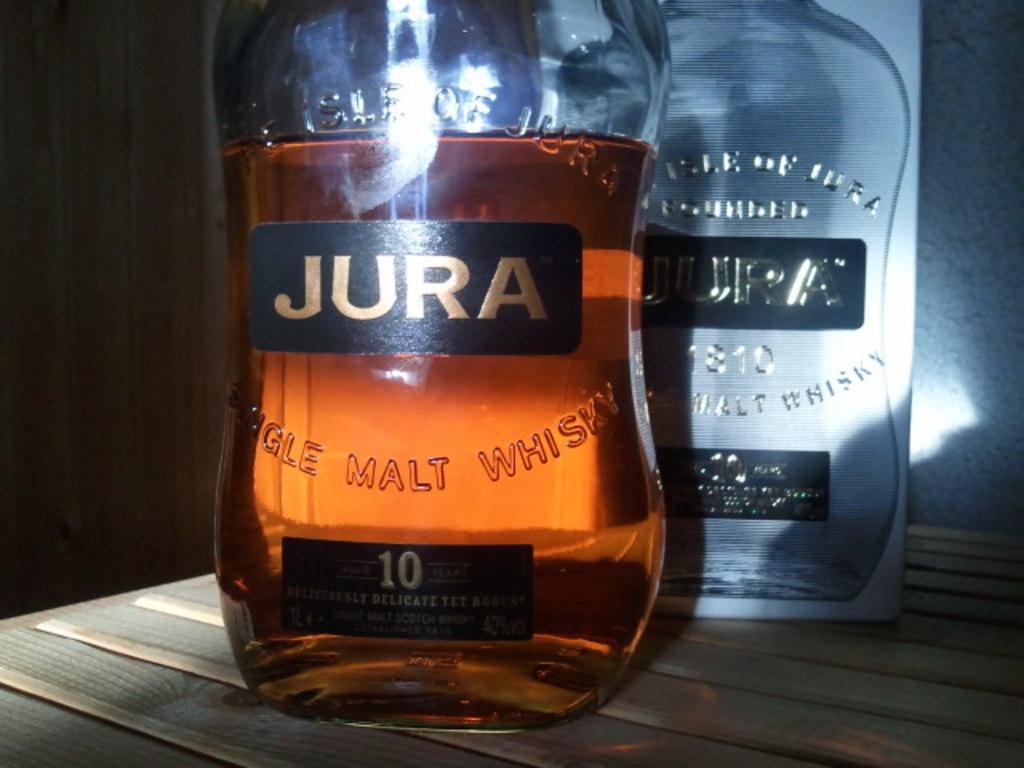What brand of whiskey is displayed?
Your answer should be very brief. Jura. 